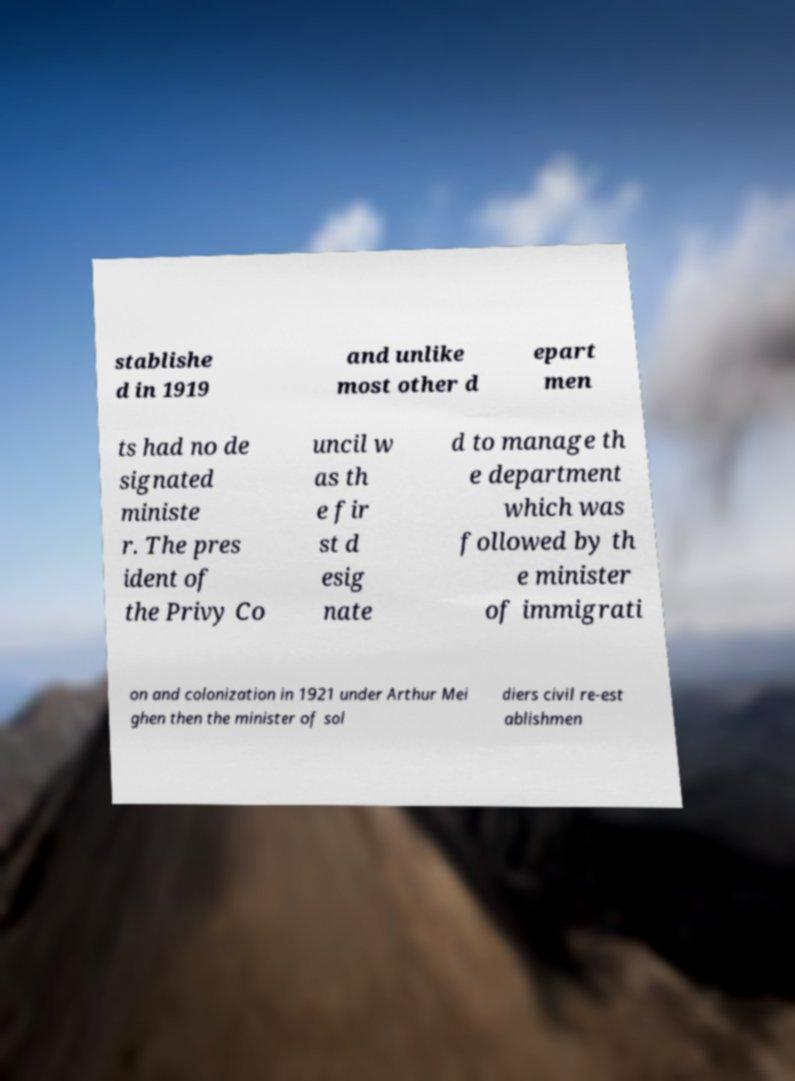For documentation purposes, I need the text within this image transcribed. Could you provide that? stablishe d in 1919 and unlike most other d epart men ts had no de signated ministe r. The pres ident of the Privy Co uncil w as th e fir st d esig nate d to manage th e department which was followed by th e minister of immigrati on and colonization in 1921 under Arthur Mei ghen then the minister of sol diers civil re-est ablishmen 